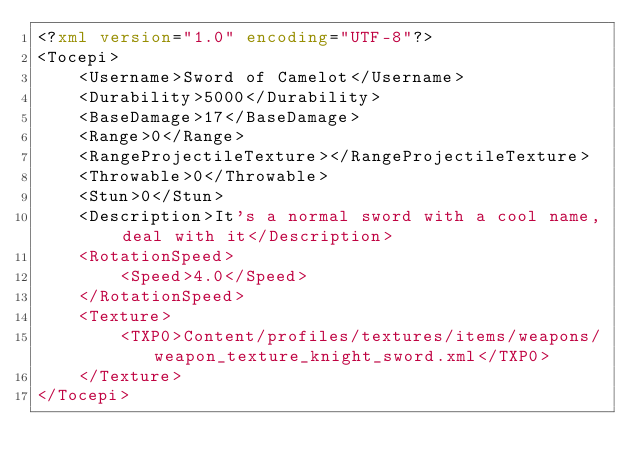<code> <loc_0><loc_0><loc_500><loc_500><_XML_><?xml version="1.0" encoding="UTF-8"?>
<Tocepi>
	<Username>Sword of Camelot</Username>
	<Durability>5000</Durability>
	<BaseDamage>17</BaseDamage>
	<Range>0</Range>
	<RangeProjectileTexture></RangeProjectileTexture>
	<Throwable>0</Throwable>
	<Stun>0</Stun>
	<Description>It's a normal sword with a cool name, deal with it</Description>
	<RotationSpeed>
		<Speed>4.0</Speed>
	</RotationSpeed>
	<Texture>
		<TXP0>Content/profiles/textures/items/weapons/weapon_texture_knight_sword.xml</TXP0>
	</Texture>
</Tocepi></code> 